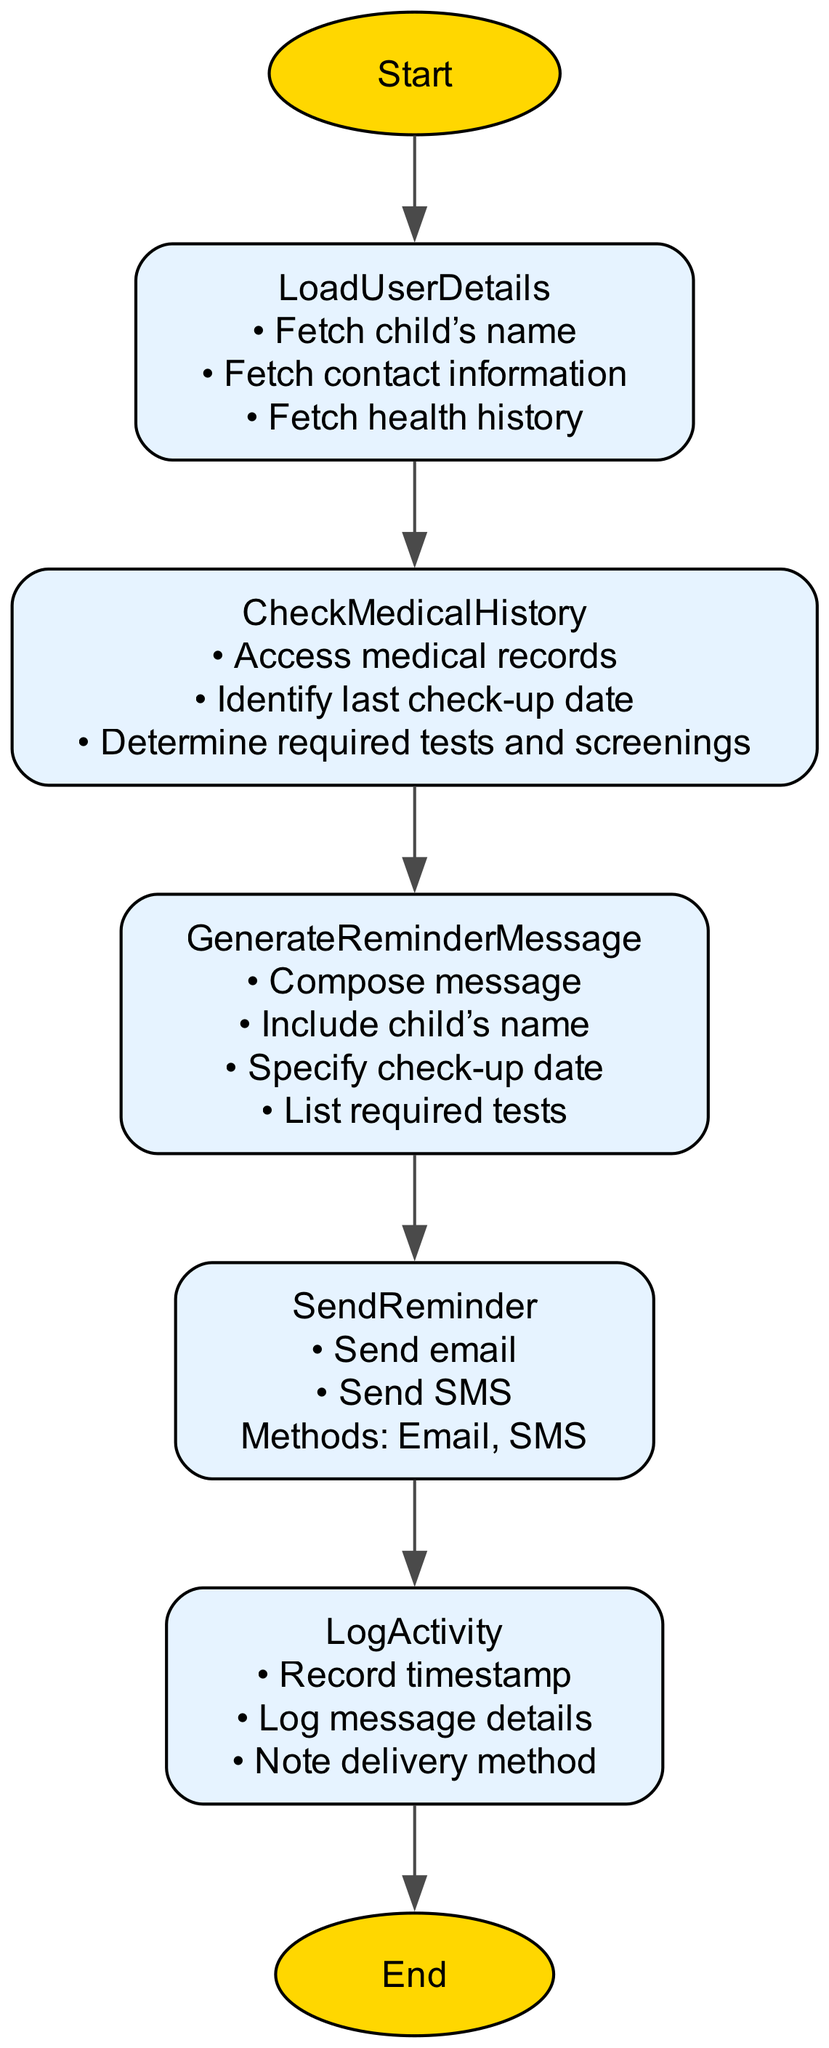What is the first step in the flowchart? The flowchart begins with the "Start" node, which serves as the initial point of the process.
Answer: Start How many actions are listed under "LoadUserDetails"? There are three actions listed under "LoadUserDetails": "Fetch child’s name", "Fetch contact information", and "Fetch health history".
Answer: 3 What is the purpose of the "CheckMedicalHistory" step? The "CheckMedicalHistory" step is designed to evaluate a child's medical history to determine their upcoming check-up needs, including accessing medical records and identifying the last check-up date.
Answer: Evaluate medical history What methods can be used to send reminders? The flowchart specifies two methods for sending reminders: via email and SMS.
Answer: Email, SMS Which node directly follows "GenerateReminderMessage"? The node that directly follows "GenerateReminderMessage" is "SendReminder", indicating that after generating the reminder message, the next step is to send it.
Answer: SendReminder What actions are performed in "LogActivity"? In the "LogActivity" step, the actions performed include recording the timestamp, logging message details, and noting the delivery method as part of the reminder process.
Answer: Record timestamp, log message details, note delivery method How many edges connect the nodes in the flowchart? The flowchart consists of six edges that connect the seven nodes. Each edge represents the flow from one step to the next.
Answer: 6 What node does the "End" belong to? The "End" node is the concluding point of the flowchart, marking the completion of the monthly health check-up announcement and reminder management process.
Answer: End What is included in the personalized reminder message created at "GenerateReminderMessage"? The personalized reminder message includes the child's name, specifies the check-up date, and lists the required tests, ensuring that the message is informative and tailored to the recipient.
Answer: Child’s name, check-up date, required tests 